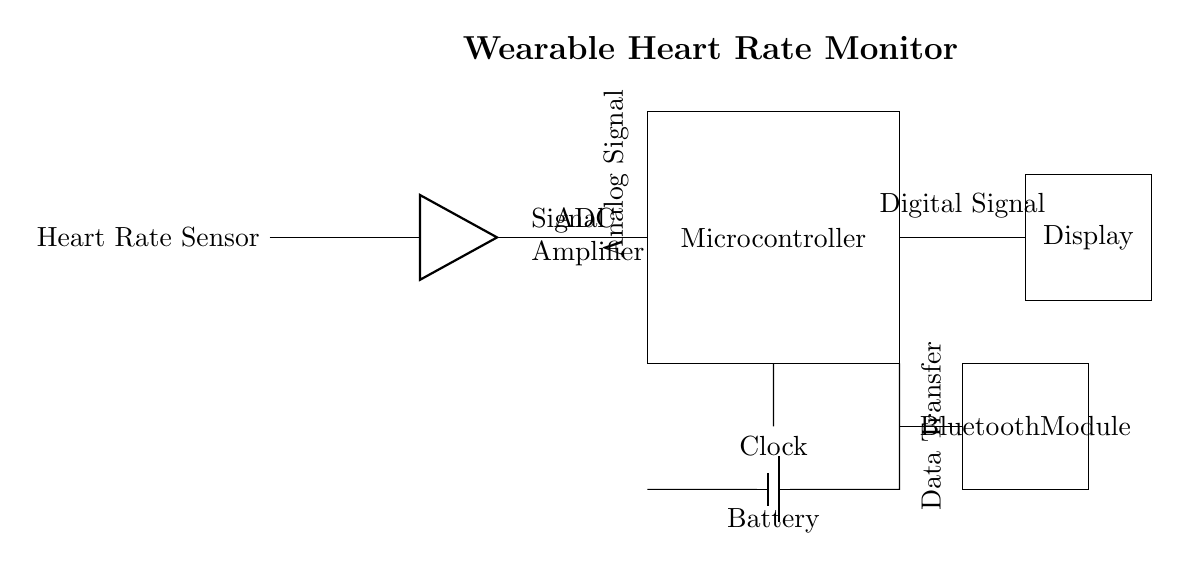What is the main component that detects heart rate? The main component is the heart rate sensor, which is shown at the beginning of the circuit diagram. It is responsible for capturing the analog signal corresponding to the heart rate.
Answer: Heart Rate Sensor What does ADC stand for in this circuit? ADC stands for Analog-to-Digital Converter, which is responsible for converting the analog signal from the heart rate sensor into a digital signal for processing by the microcontroller.
Answer: Analog-to-Digital Converter What type of signal is processed in the microcontroller? The microcontroller processes a digital signal, which comes from the ADC after the analog heart rate signal has been converted.
Answer: Digital Signal Which component is responsible for displaying the heart rate? The display component is responsible for showing the heart rate to the user. It receives the processed digital signal from the microcontroller.
Answer: Display How is data transferred to the Bluetooth module? Data is transferred from the microcontroller to the Bluetooth module via a direct connection, as indicated by the line connecting them in the circuit diagram.
Answer: Data Transfer What is the role of the clock in this circuit? The clock provides timing signals necessary for the microcontroller to execute tasks at precise intervals, ensuring correct synchronization of operations.
Answer: Timing Signals What powers the entire circuit? The battery powers the entire circuit, supplying the necessary voltage and current to operate all components, including the heart rate sensor and microcontroller.
Answer: Battery 